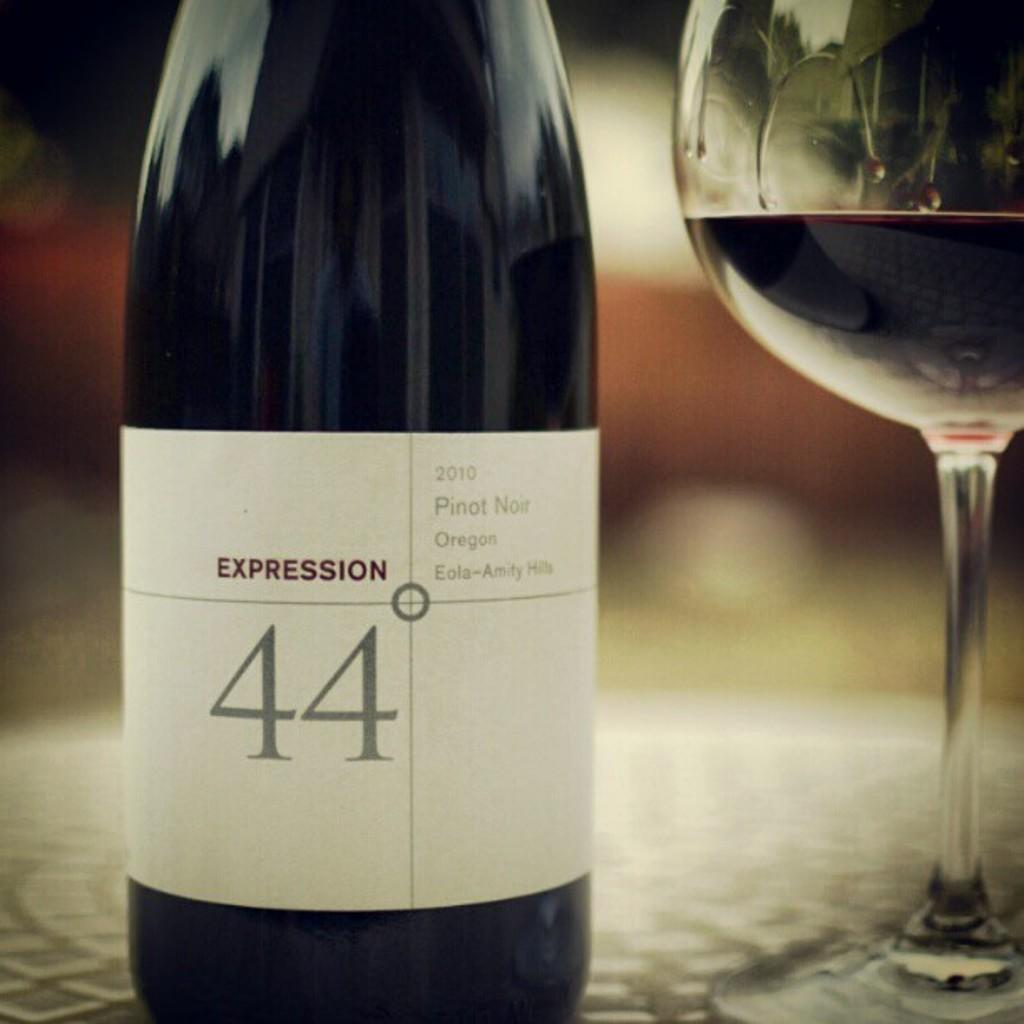<image>
Summarize the visual content of the image. A bottle of Pinot Noir is sitting on a table next to a wine glass. 